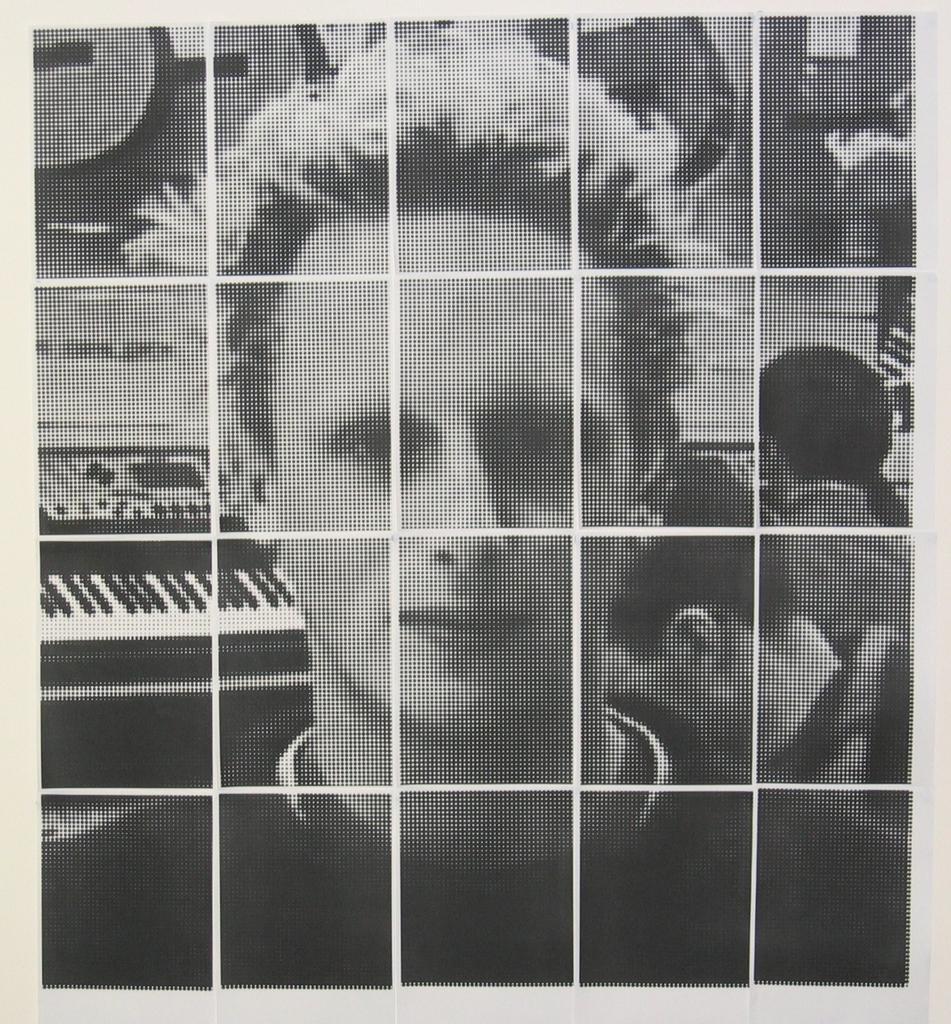Could you give a brief overview of what you see in this image? This is an edited black and white image. I can see a person. In the background, that looks like a hoarding with the picture of a piano on it. I can see two people standing. 